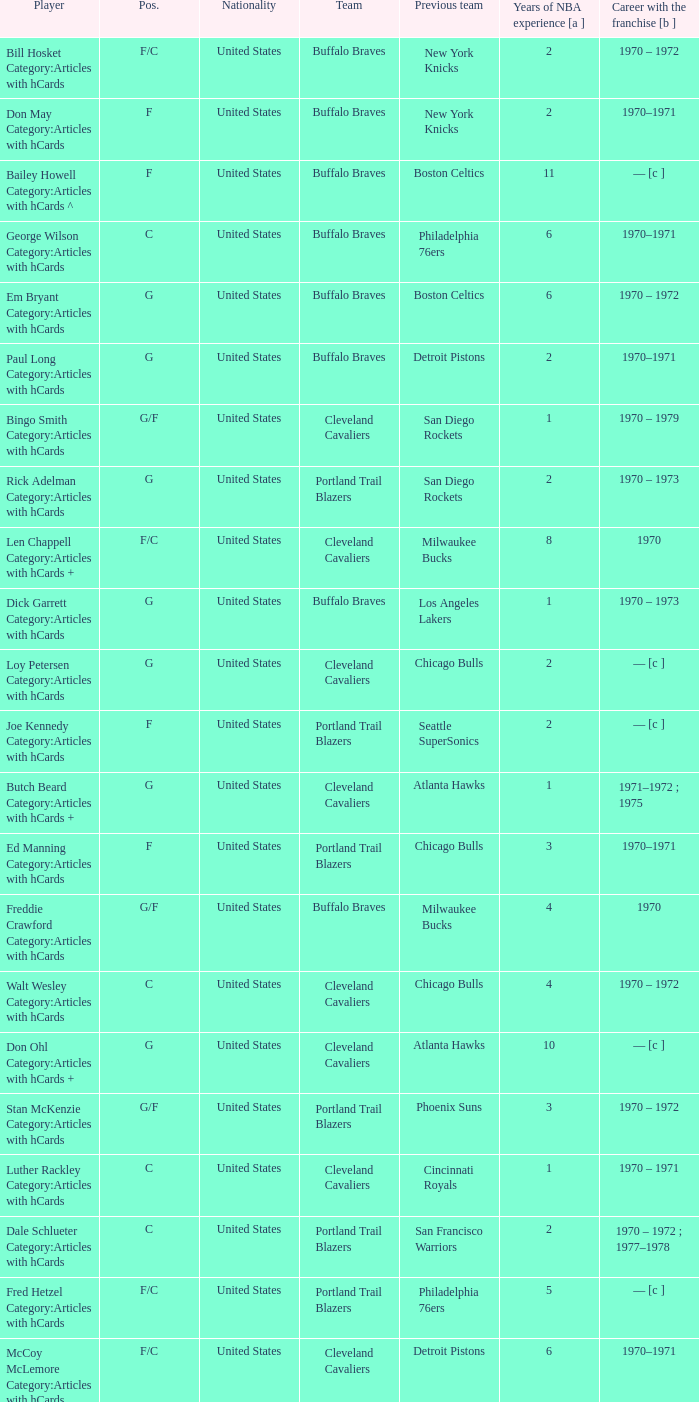How many years of NBA experience does the player who plays position g for the Portland Trail Blazers? 2.0. 